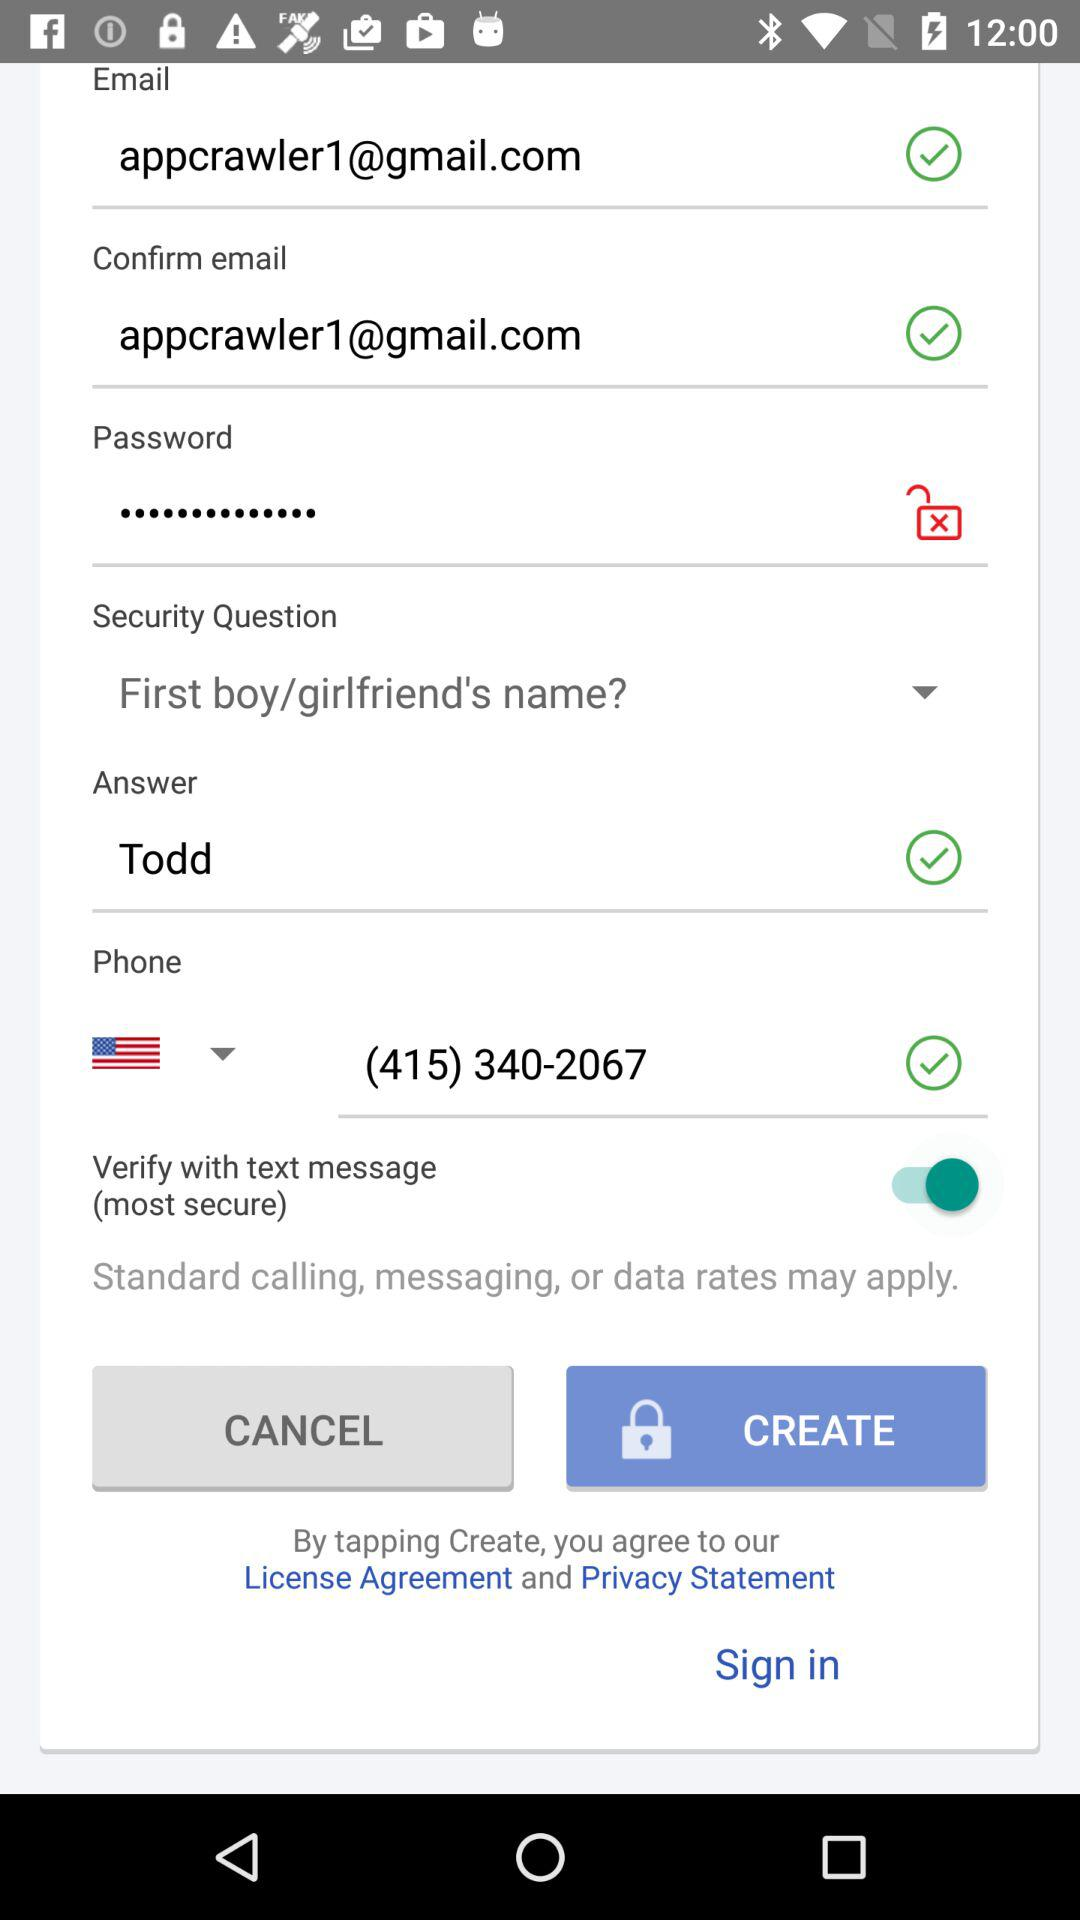What is the status of "Verify with text message"? The status is "on". 